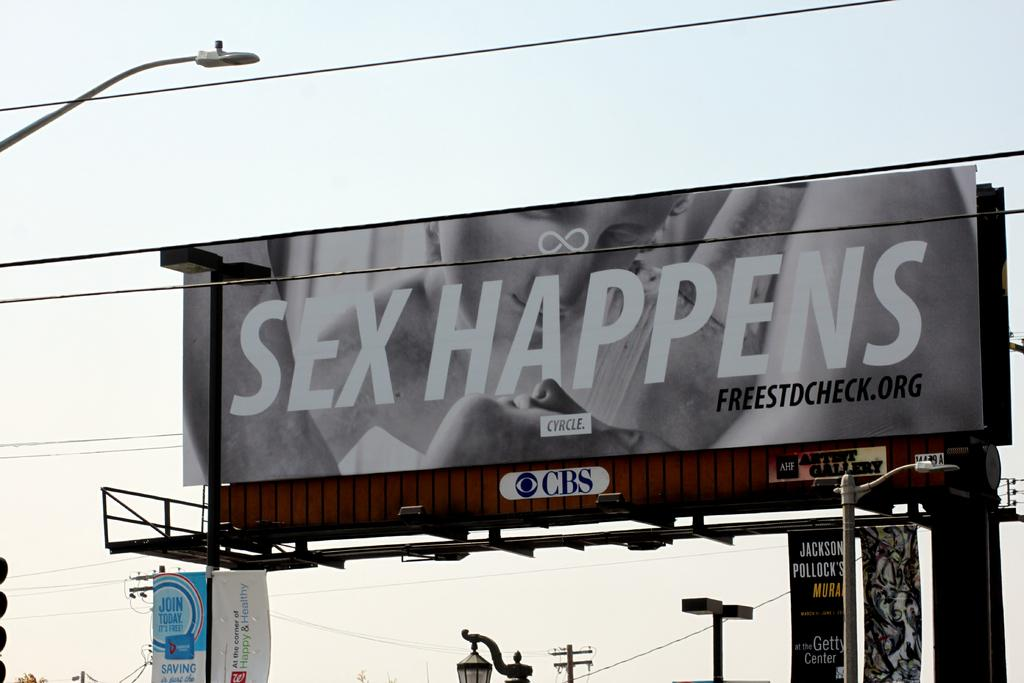<image>
Describe the image concisely. A large outdoor billboard that says Sex Happens. 